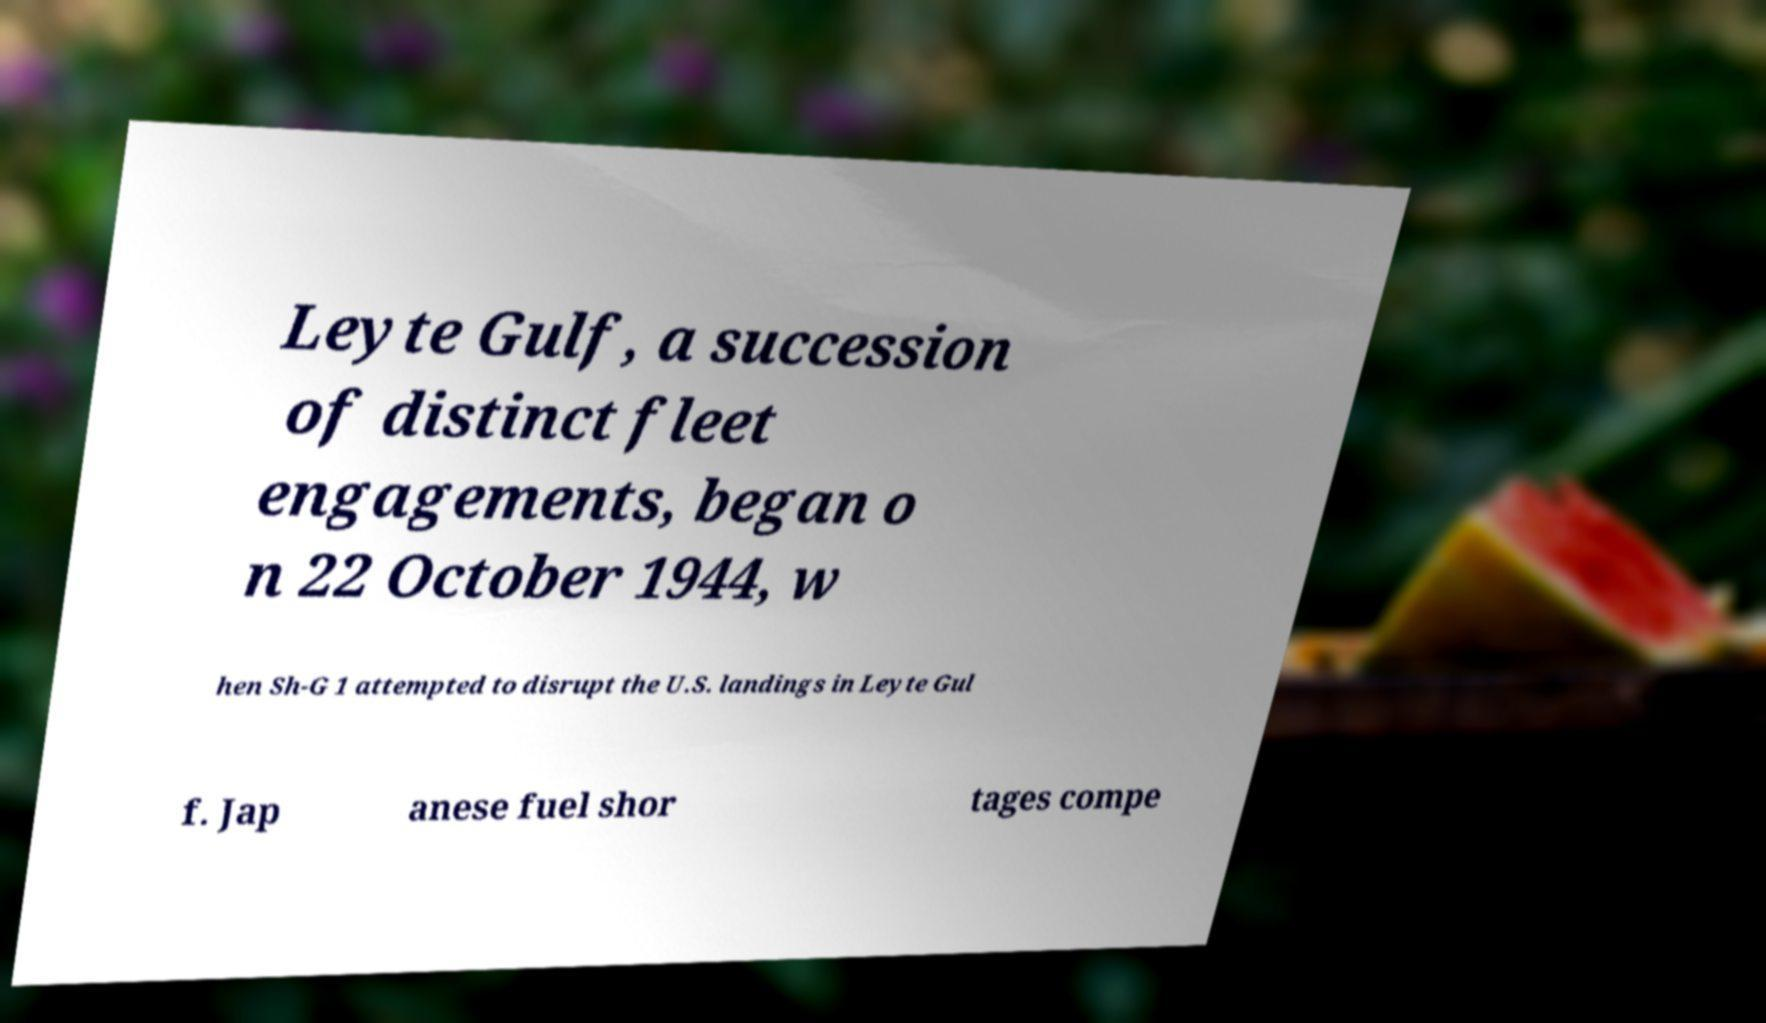Please read and relay the text visible in this image. What does it say? Leyte Gulf, a succession of distinct fleet engagements, began o n 22 October 1944, w hen Sh-G 1 attempted to disrupt the U.S. landings in Leyte Gul f. Jap anese fuel shor tages compe 